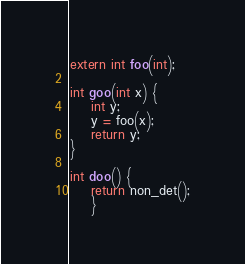Convert code to text. <code><loc_0><loc_0><loc_500><loc_500><_C_>extern int foo(int);

int goo(int x) {
	int y;
	y = foo(x);
	return y;
}

int doo() {
	return non_det();
	}

</code> 